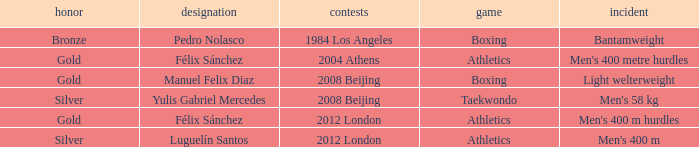Which Games had a Name of manuel felix diaz? 2008 Beijing. 